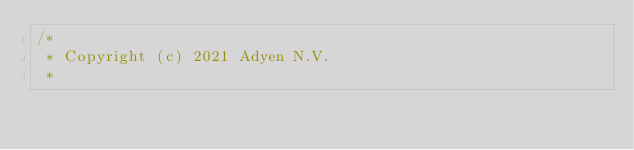Convert code to text. <code><loc_0><loc_0><loc_500><loc_500><_Kotlin_>/*
 * Copyright (c) 2021 Adyen N.V.
 *</code> 